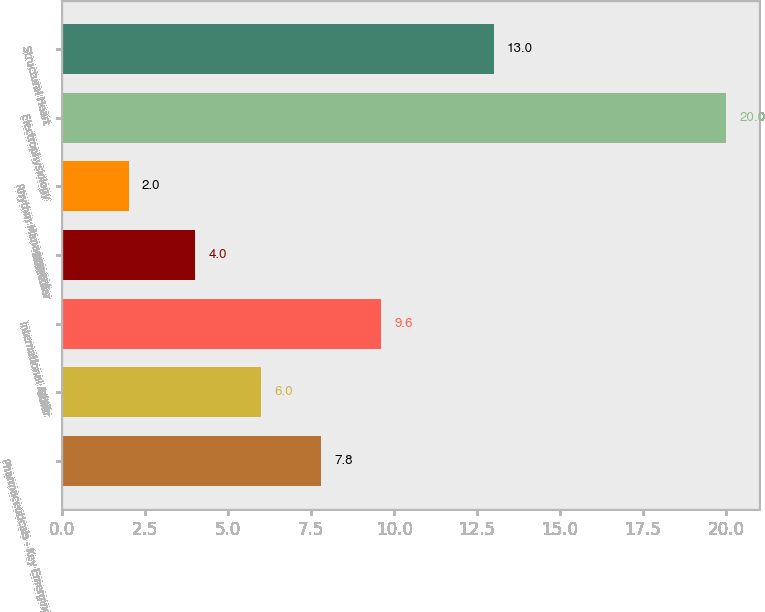Convert chart. <chart><loc_0><loc_0><loc_500><loc_500><bar_chart><fcel>Pharmaceuticals - Key Emerging<fcel>Other<fcel>International Adult<fcel>Molecular<fcel>Rhythm Management<fcel>Electrophysiology<fcel>Structural Heart<nl><fcel>7.8<fcel>6<fcel>9.6<fcel>4<fcel>2<fcel>20<fcel>13<nl></chart> 